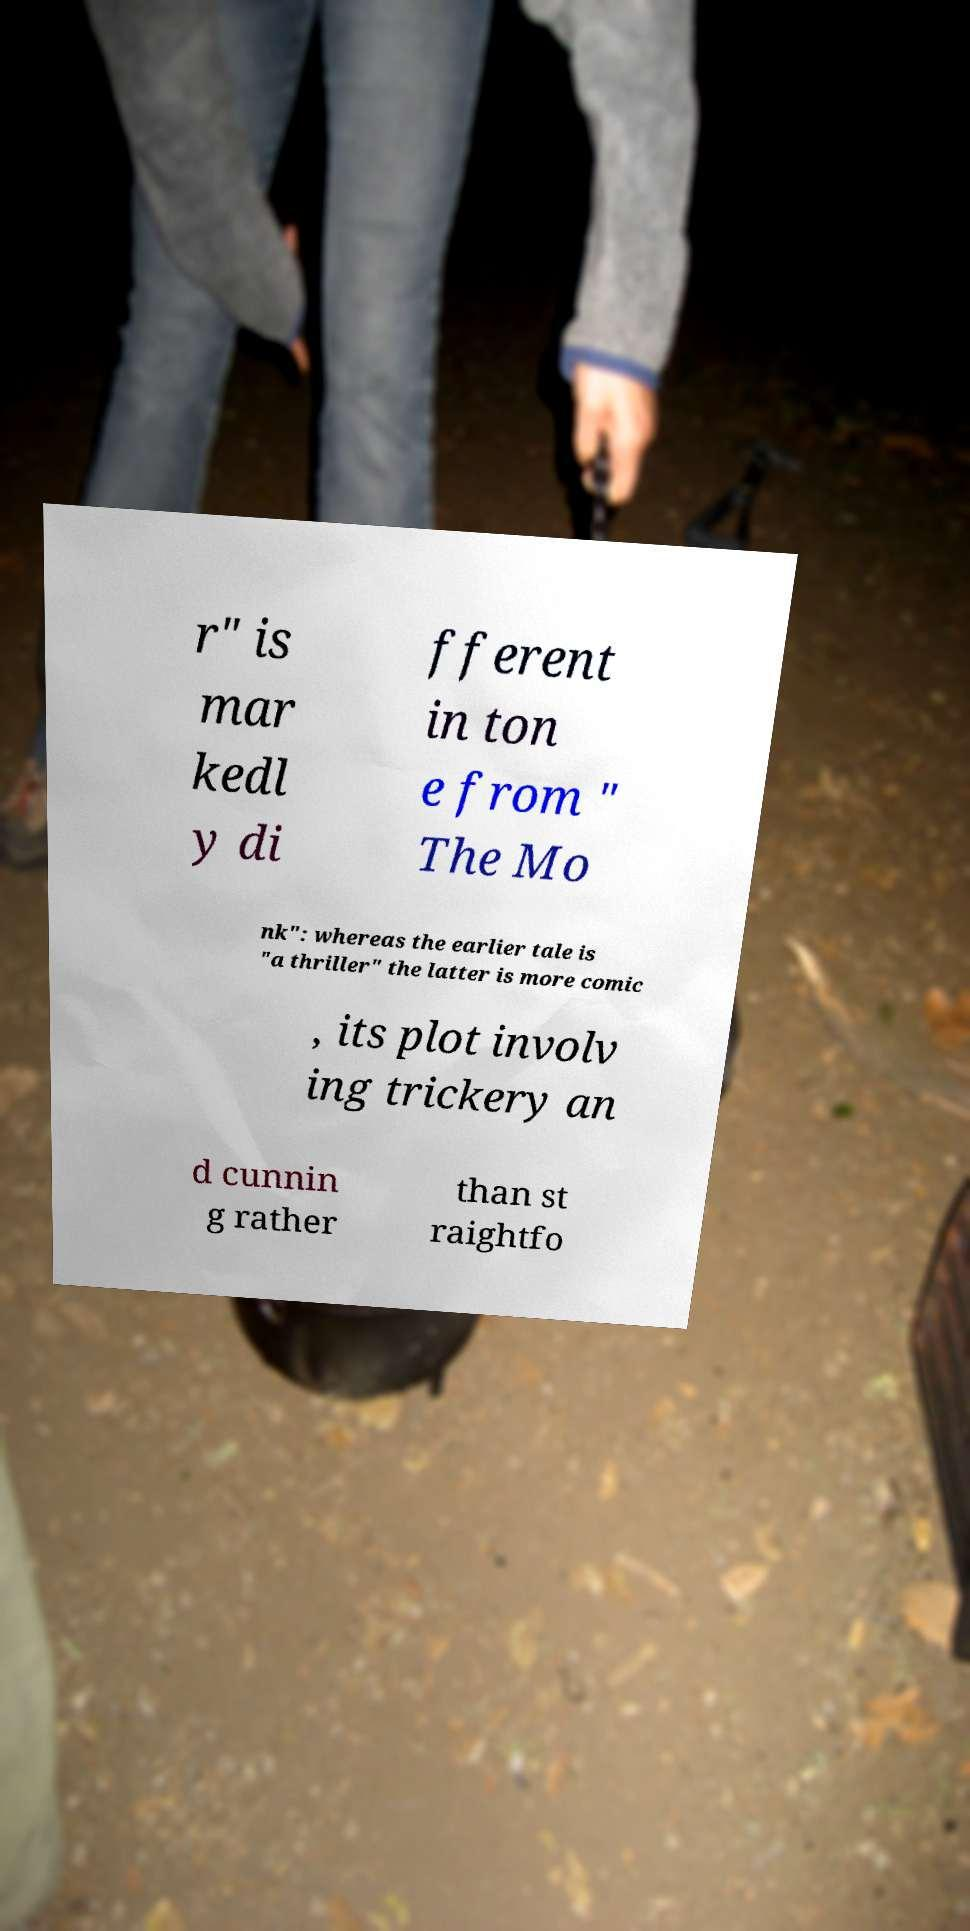Can you read and provide the text displayed in the image?This photo seems to have some interesting text. Can you extract and type it out for me? r" is mar kedl y di fferent in ton e from " The Mo nk": whereas the earlier tale is "a thriller" the latter is more comic , its plot involv ing trickery an d cunnin g rather than st raightfo 